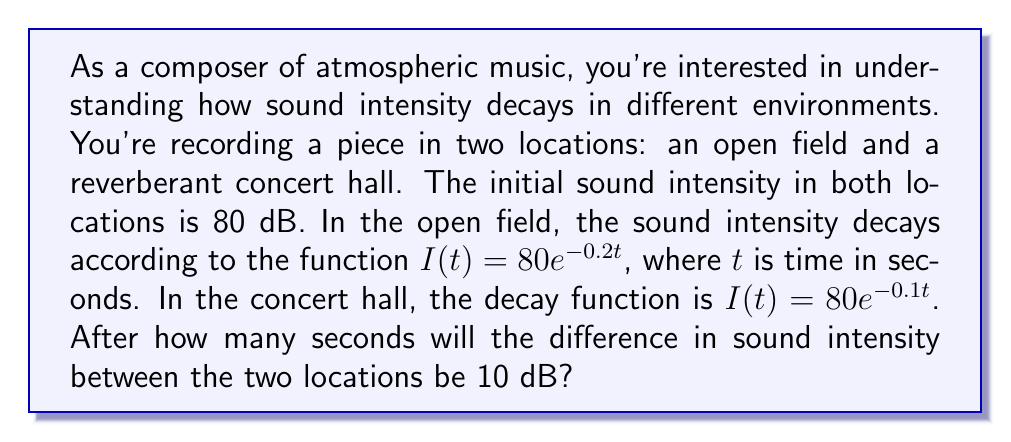Give your solution to this math problem. Let's approach this step-by-step:

1) Let $I_f(t)$ be the intensity function for the field and $I_h(t)$ for the hall:

   $I_f(t) = 80e^{-0.2t}$
   $I_h(t) = 80e^{-0.1t}$

2) We need to find $t$ when $I_h(t) - I_f(t) = 10$:

   $80e^{-0.1t} - 80e^{-0.2t} = 10$

3) Divide both sides by 80:

   $e^{-0.1t} - e^{-0.2t} = \frac{1}{8}$

4) Let $u = e^{-0.1t}$. Then $e^{-0.2t} = u^2$. Substituting:

   $u - u^2 = \frac{1}{8}$

5) Rearrange to standard quadratic form:

   $u^2 + u - \frac{1}{8} = 0$

6) Solve using the quadratic formula: $u = \frac{-b \pm \sqrt{b^2 - 4ac}}{2a}$

   $u = \frac{-1 \pm \sqrt{1 - 4(1)(-\frac{1}{8})}}{2(1)} = \frac{-1 \pm \sqrt{\frac{3}{2}}}{2}$

7) We need the positive solution: $u = \frac{-1 + \sqrt{\frac{3}{2}}}{2}$

8) Now, solve for $t$:

   $e^{-0.1t} = \frac{-1 + \sqrt{\frac{3}{2}}}{2}$

   $-0.1t = \ln(\frac{-1 + \sqrt{\frac{3}{2}}}{2})$

   $t = -10 \ln(\frac{-1 + \sqrt{\frac{3}{2}}}{2}) \approx 11.55$ seconds
Answer: The difference in sound intensity between the two locations will be 10 dB after approximately 11.55 seconds. 